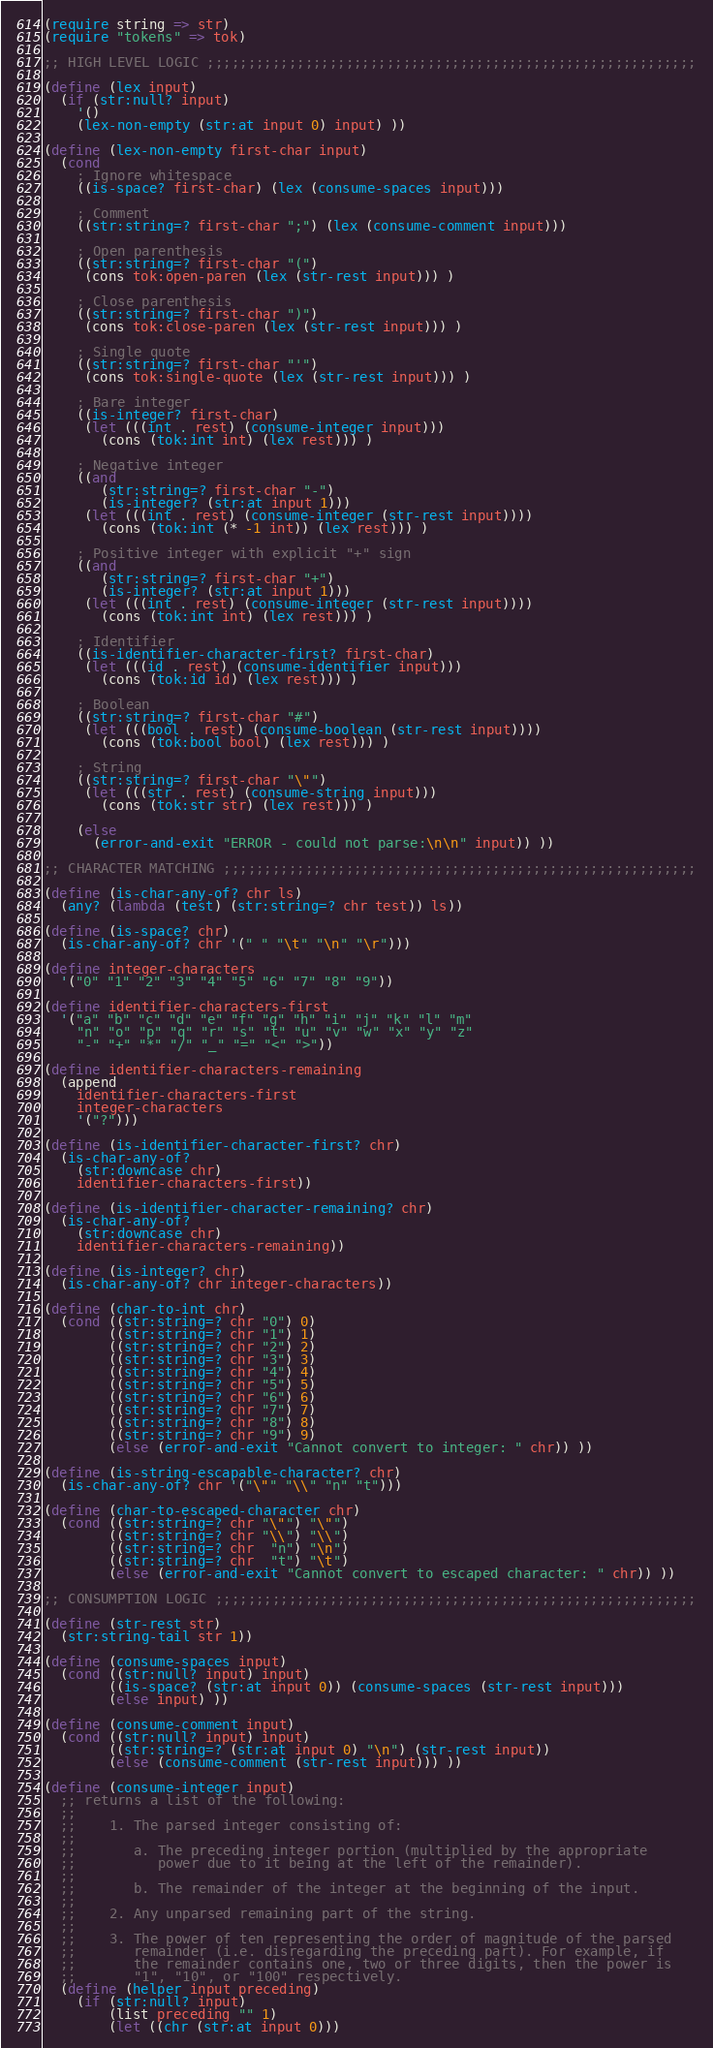Convert code to text. <code><loc_0><loc_0><loc_500><loc_500><_Scheme_>(require string => str)
(require "tokens" => tok)

;; HIGH LEVEL LOGIC ;;;;;;;;;;;;;;;;;;;;;;;;;;;;;;;;;;;;;;;;;;;;;;;;;;;;;;;;;;;;

(define (lex input)
  (if (str:null? input)
    '()
    (lex-non-empty (str:at input 0) input) ))

(define (lex-non-empty first-char input)
  (cond
    ; Ignore whitespace
    ((is-space? first-char) (lex (consume-spaces input)))

    ; Comment
    ((str:string=? first-char ";") (lex (consume-comment input)))

    ; Open parenthesis
    ((str:string=? first-char "(")
     (cons tok:open-paren (lex (str-rest input))) )

    ; Close parenthesis
    ((str:string=? first-char ")")
     (cons tok:close-paren (lex (str-rest input))) )

    ; Single quote
    ((str:string=? first-char "'")
     (cons tok:single-quote (lex (str-rest input))) )

    ; Bare integer
    ((is-integer? first-char)
     (let (((int . rest) (consume-integer input)))
       (cons (tok:int int) (lex rest))) )

    ; Negative integer
    ((and
       (str:string=? first-char "-")
       (is-integer? (str:at input 1)))
     (let (((int . rest) (consume-integer (str-rest input))))
       (cons (tok:int (* -1 int)) (lex rest))) )

    ; Positive integer with explicit "+" sign
    ((and
       (str:string=? first-char "+")
       (is-integer? (str:at input 1)))
     (let (((int . rest) (consume-integer (str-rest input))))
       (cons (tok:int int) (lex rest))) )

    ; Identifier
    ((is-identifier-character-first? first-char)
     (let (((id . rest) (consume-identifier input)))
       (cons (tok:id id) (lex rest))) )

    ; Boolean
    ((str:string=? first-char "#")
     (let (((bool . rest) (consume-boolean (str-rest input))))
       (cons (tok:bool bool) (lex rest))) )

    ; String
    ((str:string=? first-char "\"")
     (let (((str . rest) (consume-string input)))
       (cons (tok:str str) (lex rest))) )

    (else
      (error-and-exit "ERROR - could not parse:\n\n" input)) ))

;; CHARACTER MATCHING ;;;;;;;;;;;;;;;;;;;;;;;;;;;;;;;;;;;;;;;;;;;;;;;;;;;;;;;;;;

(define (is-char-any-of? chr ls)
  (any? (lambda (test) (str:string=? chr test)) ls))

(define (is-space? chr)
  (is-char-any-of? chr '(" " "\t" "\n" "\r")))

(define integer-characters
  '("0" "1" "2" "3" "4" "5" "6" "7" "8" "9"))

(define identifier-characters-first
  '("a" "b" "c" "d" "e" "f" "g" "h" "i" "j" "k" "l" "m"
    "n" "o" "p" "q" "r" "s" "t" "u" "v" "w" "x" "y" "z"
    "-" "+" "*" "/" "_" "=" "<" ">"))

(define identifier-characters-remaining
  (append
    identifier-characters-first
    integer-characters
    '("?")))

(define (is-identifier-character-first? chr)
  (is-char-any-of?
    (str:downcase chr)
    identifier-characters-first))

(define (is-identifier-character-remaining? chr)
  (is-char-any-of?
    (str:downcase chr)
    identifier-characters-remaining))

(define (is-integer? chr)
  (is-char-any-of? chr integer-characters))

(define (char-to-int chr)
  (cond ((str:string=? chr "0") 0)
        ((str:string=? chr "1") 1)
        ((str:string=? chr "2") 2)
        ((str:string=? chr "3") 3)
        ((str:string=? chr "4") 4)
        ((str:string=? chr "5") 5)
        ((str:string=? chr "6") 6)
        ((str:string=? chr "7") 7)
        ((str:string=? chr "8") 8)
        ((str:string=? chr "9") 9)
        (else (error-and-exit "Cannot convert to integer: " chr)) ))

(define (is-string-escapable-character? chr)
  (is-char-any-of? chr '("\"" "\\" "n" "t")))

(define (char-to-escaped-character chr)
  (cond ((str:string=? chr "\"") "\"")
        ((str:string=? chr "\\") "\\")
        ((str:string=? chr  "n") "\n")
        ((str:string=? chr  "t") "\t")
        (else (error-and-exit "Cannot convert to escaped character: " chr)) ))

;; CONSUMPTION LOGIC ;;;;;;;;;;;;;;;;;;;;;;;;;;;;;;;;;;;;;;;;;;;;;;;;;;;;;;;;;;;

(define (str-rest str)
  (str:string-tail str 1))

(define (consume-spaces input)
  (cond ((str:null? input) input)
        ((is-space? (str:at input 0)) (consume-spaces (str-rest input)))
        (else input) ))

(define (consume-comment input)
  (cond ((str:null? input) input)
        ((str:string=? (str:at input 0) "\n") (str-rest input))
        (else (consume-comment (str-rest input))) ))

(define (consume-integer input)
  ;; returns a list of the following:
  ;;
  ;;    1. The parsed integer consisting of:
  ;;
  ;;       a. The preceding integer portion (multiplied by the appropriate
  ;;          power due to it being at the left of the remainder).
  ;;
  ;;       b. The remainder of the integer at the beginning of the input.
  ;;
  ;;    2. Any unparsed remaining part of the string.
  ;;
  ;;    3. The power of ten representing the order of magnitude of the parsed
  ;;       remainder (i.e. disregarding the preceding part). For example, if
  ;;       the remainder contains one, two or three digits, then the power is
  ;;       "1", "10", or "100" respectively.
  (define (helper input preceding)
    (if (str:null? input)
        (list preceding "" 1)
        (let ((chr (str:at input 0)))</code> 